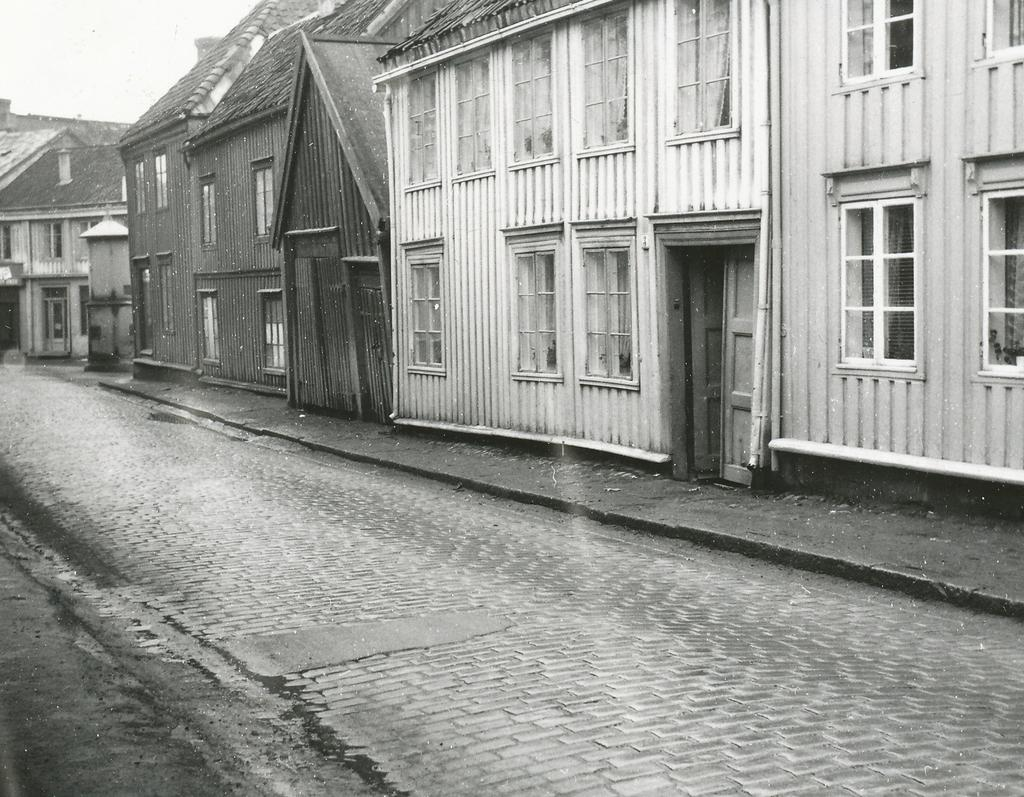What is the color scheme of the image? The image is black and white. What type of structures can be seen in the image? There is a group of houses in the image. What features do the houses have? The houses have roofs, windows, and doors. What can be seen on the ground in the image? There is a pathway visible in the image. What is visible in the background of the image? The sky is visible in the image. Where is the basket of apples located in the image? There is no basket of apples present in the image. What type of boats can be seen in the harbor in the image? There is no harbor or boats present in the image. 